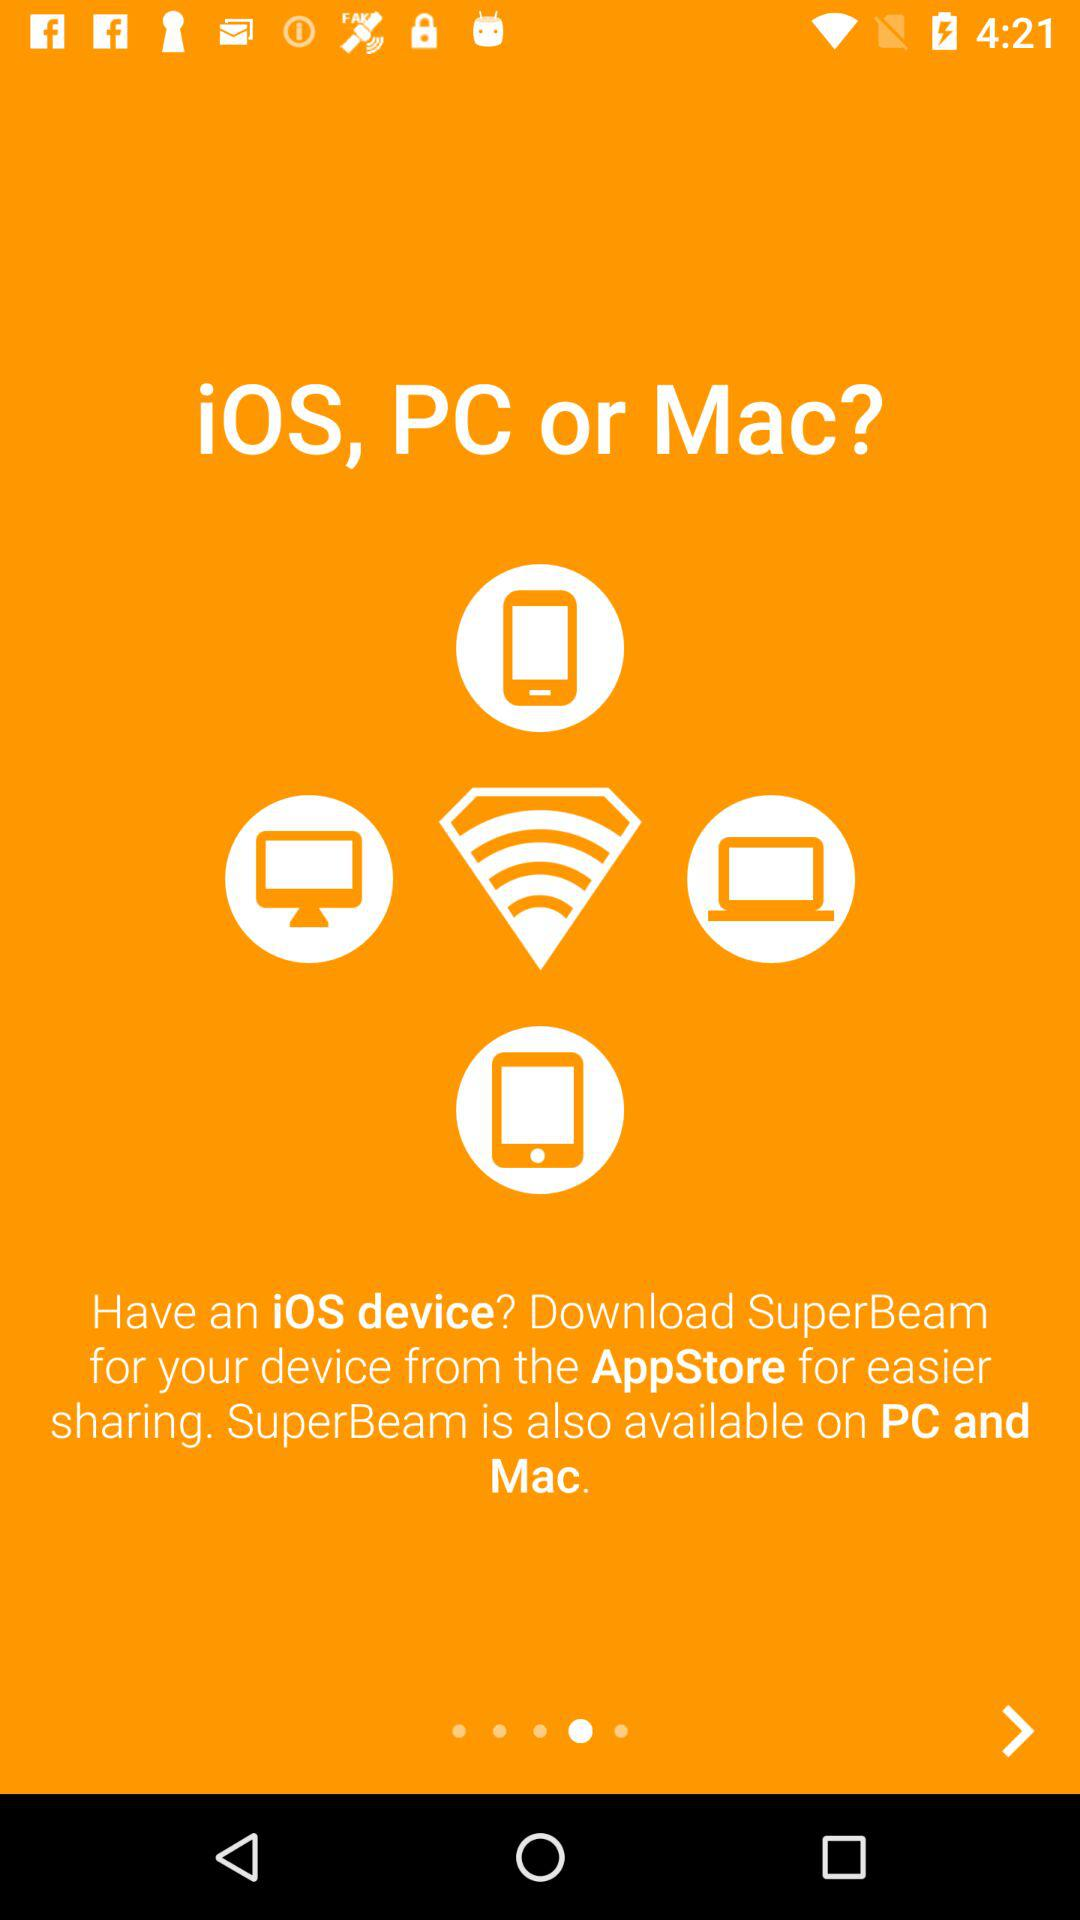On which devices is the application available? The application is available on iOS, PC and Mac. 